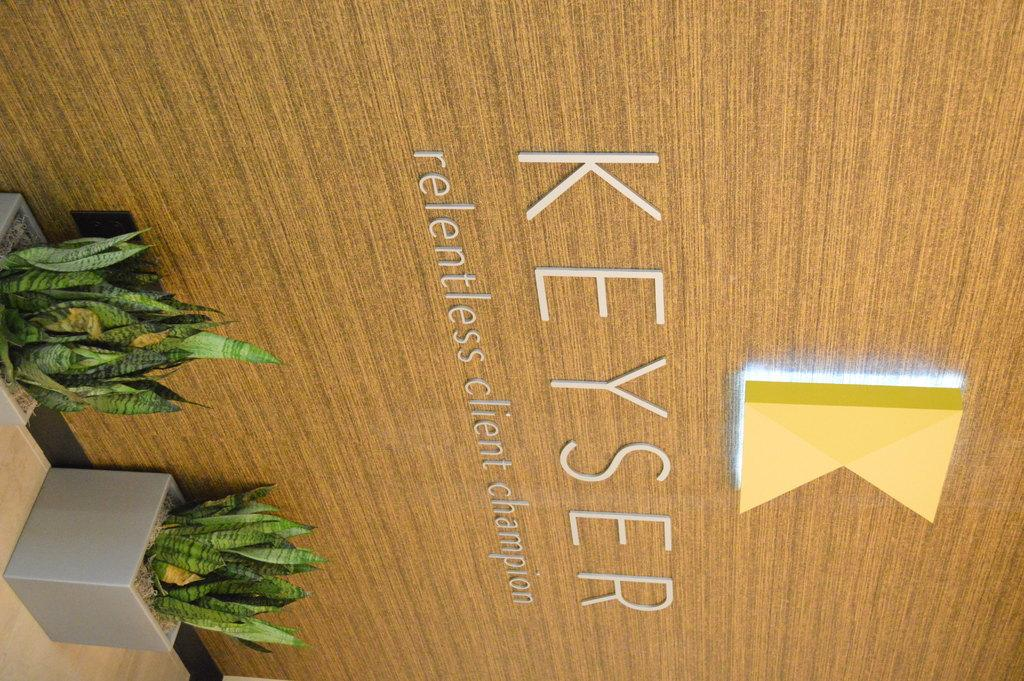What is written or depicted on the wall in the image? There is a wall with text in the image. What type of plants are in the image? There are plants in pots in the image. Can you describe the logo in the image? There is a logo with a light in the image. What type of machine is performing on the stage in the image? There is no machine or stage present in the image. How much paste is needed to cover the text on the wall in the image? There is no mention of paste or any need to cover the text on the wall in the image. 